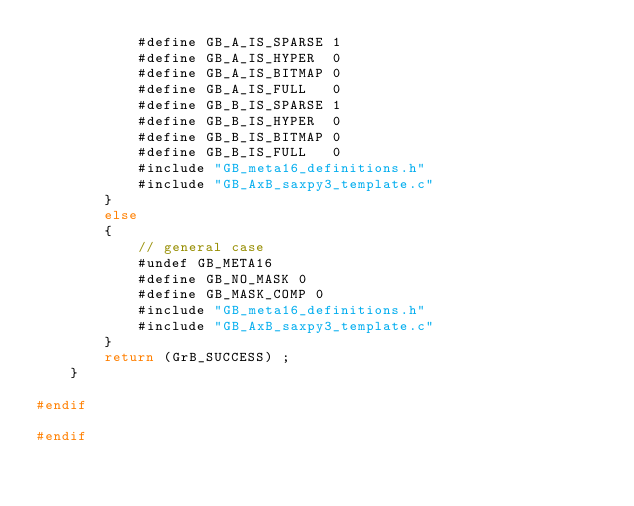<code> <loc_0><loc_0><loc_500><loc_500><_C_>            #define GB_A_IS_SPARSE 1
            #define GB_A_IS_HYPER  0
            #define GB_A_IS_BITMAP 0
            #define GB_A_IS_FULL   0
            #define GB_B_IS_SPARSE 1
            #define GB_B_IS_HYPER  0
            #define GB_B_IS_BITMAP 0
            #define GB_B_IS_FULL   0
            #include "GB_meta16_definitions.h"
            #include "GB_AxB_saxpy3_template.c"
        }
        else
        {
            // general case
            #undef GB_META16
            #define GB_NO_MASK 0
            #define GB_MASK_COMP 0
            #include "GB_meta16_definitions.h"
            #include "GB_AxB_saxpy3_template.c"
        }
        return (GrB_SUCCESS) ;
    }

#endif

#endif

</code> 